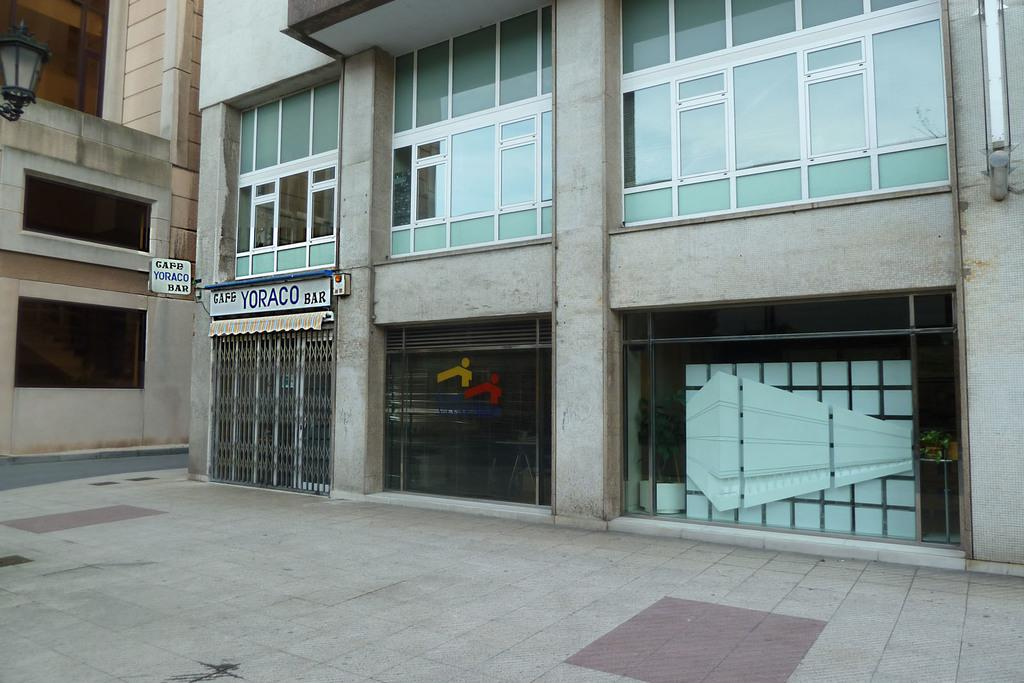What type of structures can be seen in the image? There are buildings in the image. What is written on the boards in the image? There are boards with words written on them in the image. What can be used for illumination in the image? There is a light visible in the image. What is a possible route for walking or driving in the image? There is a path in the image. What allows natural light to enter the buildings in the image? There are windows visible in the image. Can you tell me how many firemen are present in the image? There is no fireman present in the image. What type of person can be seen exchanging goods in the image? There is no person or exchange of goods depicted in the image. 